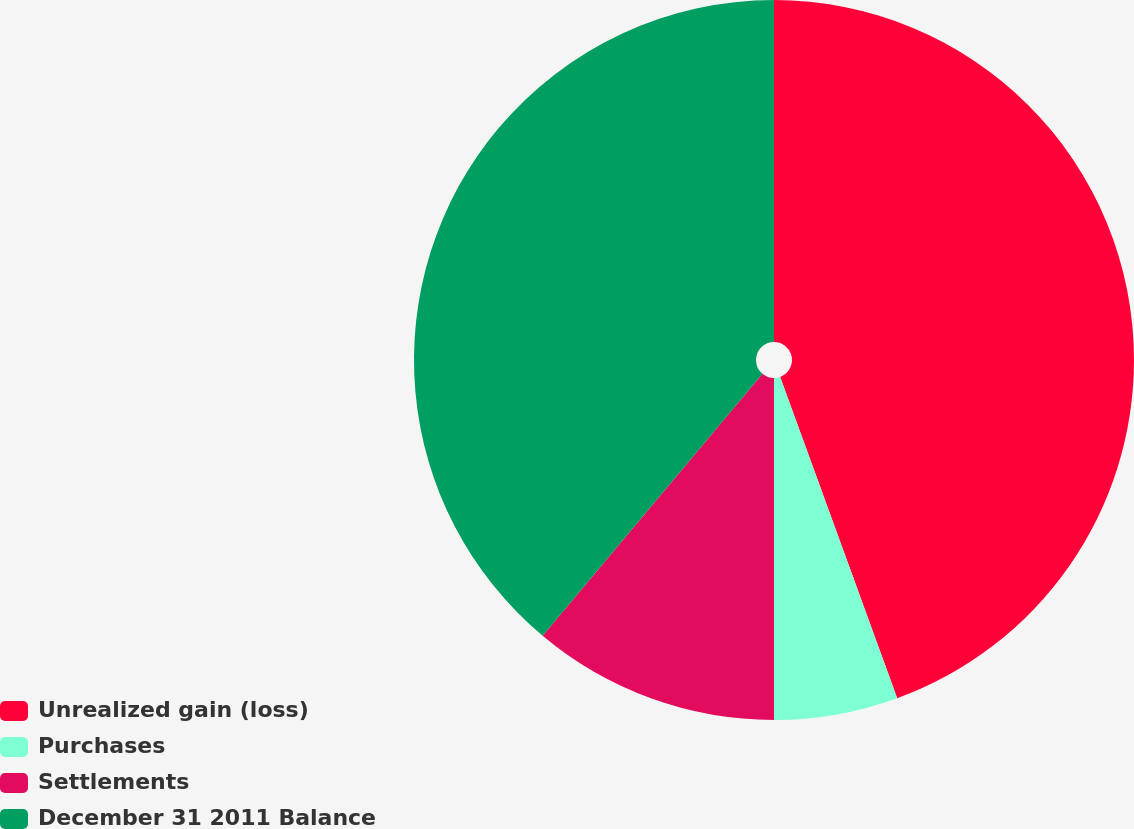Convert chart. <chart><loc_0><loc_0><loc_500><loc_500><pie_chart><fcel>Unrealized gain (loss)<fcel>Purchases<fcel>Settlements<fcel>December 31 2011 Balance<nl><fcel>44.44%<fcel>5.56%<fcel>11.11%<fcel>38.89%<nl></chart> 